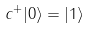<formula> <loc_0><loc_0><loc_500><loc_500>c ^ { + } | 0 \rangle = | 1 \rangle</formula> 